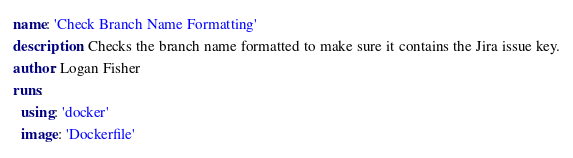<code> <loc_0><loc_0><loc_500><loc_500><_YAML_>name: 'Check Branch Name Formatting'
description: Checks the branch name formatted to make sure it contains the Jira issue key.
author: Logan Fisher
runs:
  using: 'docker'
  image: 'Dockerfile'</code> 